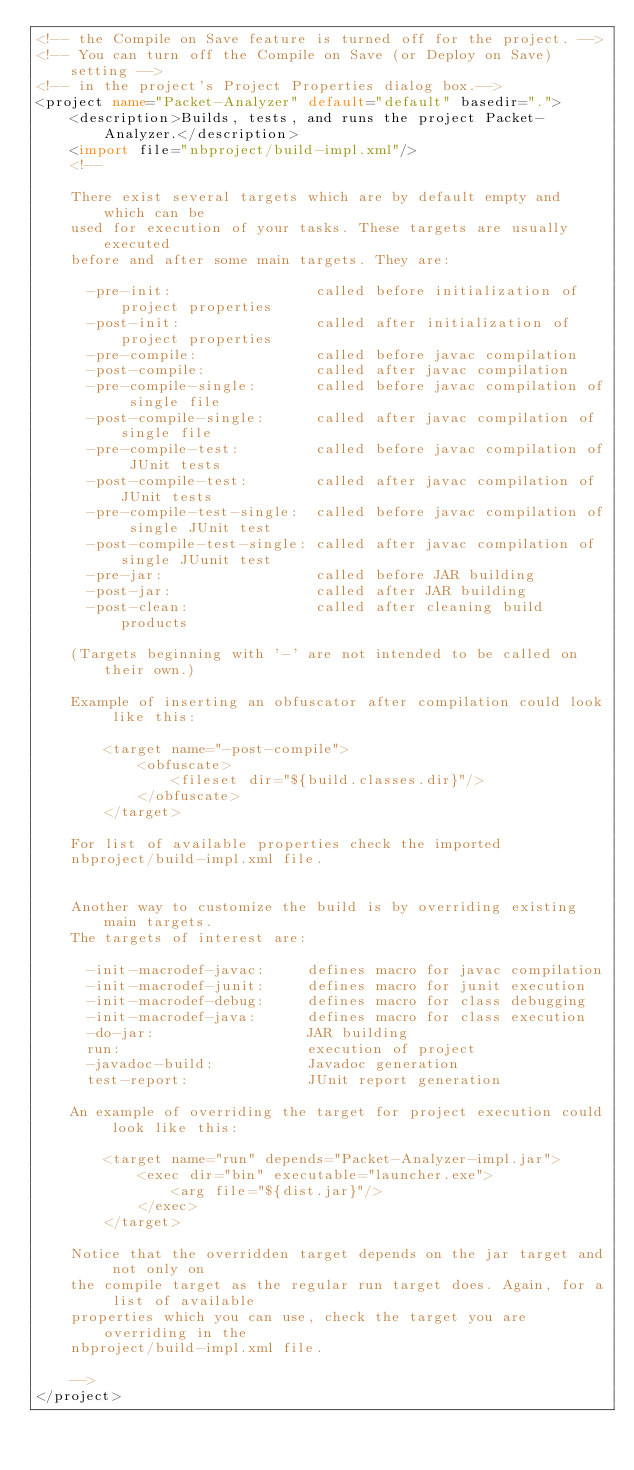Convert code to text. <code><loc_0><loc_0><loc_500><loc_500><_XML_><!-- the Compile on Save feature is turned off for the project. -->
<!-- You can turn off the Compile on Save (or Deploy on Save) setting -->
<!-- in the project's Project Properties dialog box.-->
<project name="Packet-Analyzer" default="default" basedir=".">
    <description>Builds, tests, and runs the project Packet-Analyzer.</description>
    <import file="nbproject/build-impl.xml"/>
    <!--

    There exist several targets which are by default empty and which can be 
    used for execution of your tasks. These targets are usually executed 
    before and after some main targets. They are: 

      -pre-init:                 called before initialization of project properties
      -post-init:                called after initialization of project properties
      -pre-compile:              called before javac compilation
      -post-compile:             called after javac compilation
      -pre-compile-single:       called before javac compilation of single file
      -post-compile-single:      called after javac compilation of single file
      -pre-compile-test:         called before javac compilation of JUnit tests
      -post-compile-test:        called after javac compilation of JUnit tests
      -pre-compile-test-single:  called before javac compilation of single JUnit test
      -post-compile-test-single: called after javac compilation of single JUunit test
      -pre-jar:                  called before JAR building
      -post-jar:                 called after JAR building
      -post-clean:               called after cleaning build products

    (Targets beginning with '-' are not intended to be called on their own.)

    Example of inserting an obfuscator after compilation could look like this:

        <target name="-post-compile">
            <obfuscate>
                <fileset dir="${build.classes.dir}"/>
            </obfuscate>
        </target>

    For list of available properties check the imported 
    nbproject/build-impl.xml file. 


    Another way to customize the build is by overriding existing main targets.
    The targets of interest are: 

      -init-macrodef-javac:     defines macro for javac compilation
      -init-macrodef-junit:     defines macro for junit execution
      -init-macrodef-debug:     defines macro for class debugging
      -init-macrodef-java:      defines macro for class execution
      -do-jar:                  JAR building
      run:                      execution of project 
      -javadoc-build:           Javadoc generation
      test-report:              JUnit report generation

    An example of overriding the target for project execution could look like this:

        <target name="run" depends="Packet-Analyzer-impl.jar">
            <exec dir="bin" executable="launcher.exe">
                <arg file="${dist.jar}"/>
            </exec>
        </target>

    Notice that the overridden target depends on the jar target and not only on 
    the compile target as the regular run target does. Again, for a list of available 
    properties which you can use, check the target you are overriding in the
    nbproject/build-impl.xml file. 

    -->
</project>
</code> 